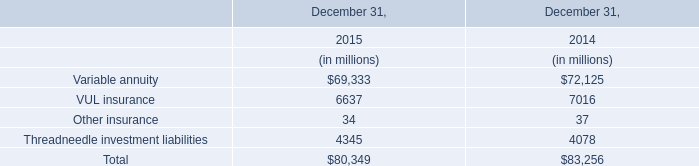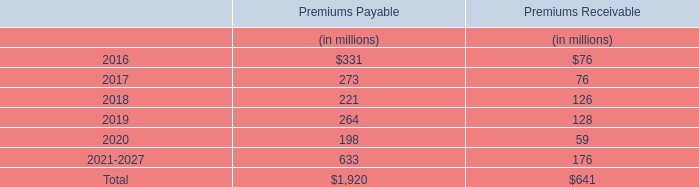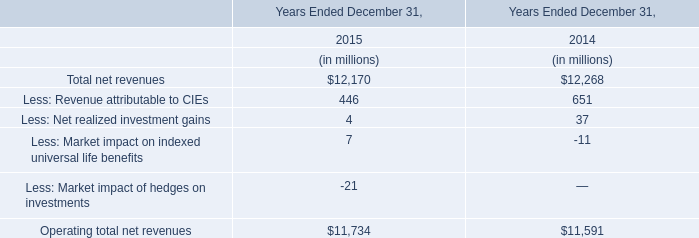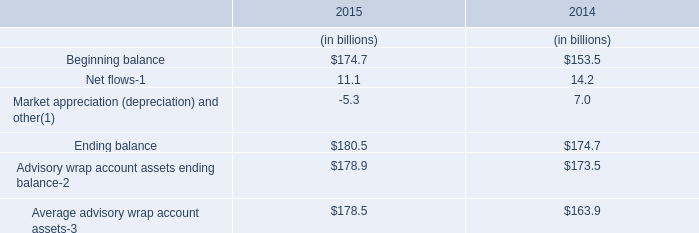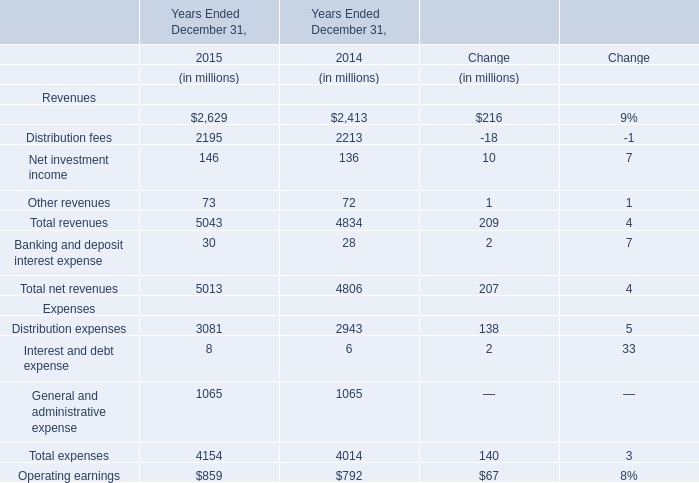What's the total amount of Management and financial advice fees, Distribution fees, Net investment income and Other revenues in 2015? (in millions) 
Computations: (((2629 + 2195) + 146) + 73)
Answer: 5043.0. 